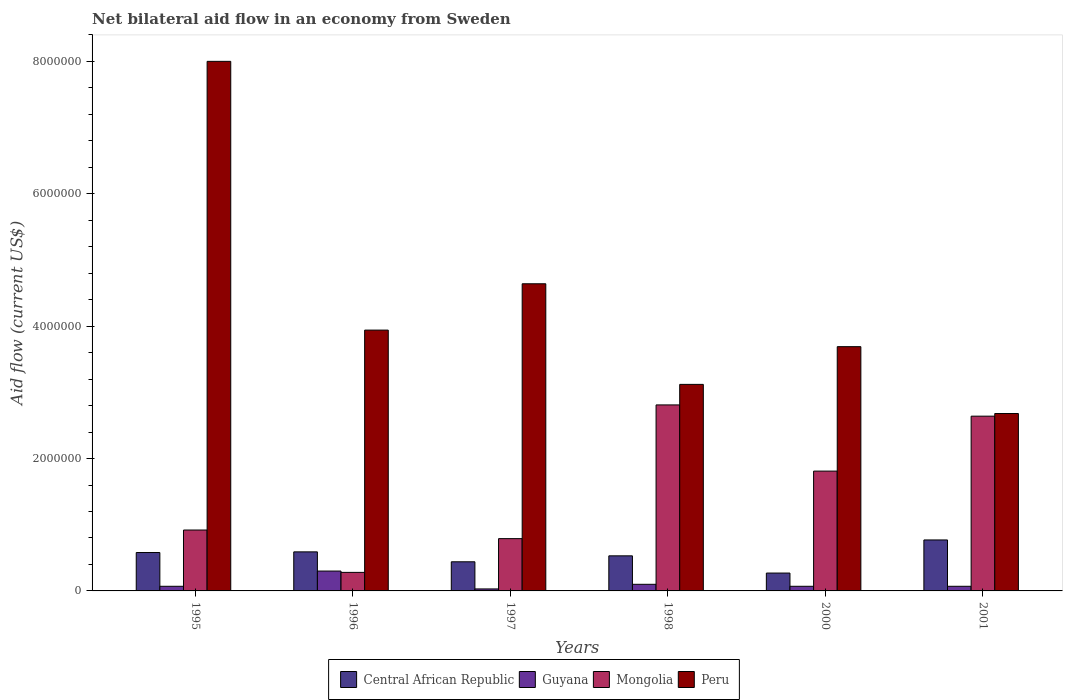How many different coloured bars are there?
Offer a very short reply. 4. How many groups of bars are there?
Make the answer very short. 6. Are the number of bars on each tick of the X-axis equal?
Make the answer very short. Yes. What is the net bilateral aid flow in Guyana in 2001?
Provide a short and direct response. 7.00e+04. Across all years, what is the minimum net bilateral aid flow in Central African Republic?
Make the answer very short. 2.70e+05. What is the total net bilateral aid flow in Mongolia in the graph?
Make the answer very short. 9.25e+06. What is the difference between the net bilateral aid flow in Mongolia in 1997 and that in 2000?
Give a very brief answer. -1.02e+06. What is the difference between the net bilateral aid flow in Mongolia in 1997 and the net bilateral aid flow in Central African Republic in 2001?
Make the answer very short. 2.00e+04. What is the average net bilateral aid flow in Guyana per year?
Provide a succinct answer. 1.07e+05. In the year 2000, what is the difference between the net bilateral aid flow in Central African Republic and net bilateral aid flow in Guyana?
Your answer should be very brief. 2.00e+05. What is the ratio of the net bilateral aid flow in Mongolia in 1996 to that in 2001?
Your response must be concise. 0.11. Is the net bilateral aid flow in Guyana in 1995 less than that in 1996?
Your response must be concise. Yes. Is the difference between the net bilateral aid flow in Central African Republic in 1997 and 2000 greater than the difference between the net bilateral aid flow in Guyana in 1997 and 2000?
Give a very brief answer. Yes. What does the 3rd bar from the left in 1998 represents?
Offer a very short reply. Mongolia. How many bars are there?
Provide a short and direct response. 24. Are all the bars in the graph horizontal?
Your answer should be compact. No. How many years are there in the graph?
Ensure brevity in your answer.  6. Are the values on the major ticks of Y-axis written in scientific E-notation?
Provide a short and direct response. No. Where does the legend appear in the graph?
Give a very brief answer. Bottom center. What is the title of the graph?
Your response must be concise. Net bilateral aid flow in an economy from Sweden. Does "Sub-Saharan Africa (developing only)" appear as one of the legend labels in the graph?
Keep it short and to the point. No. What is the Aid flow (current US$) of Central African Republic in 1995?
Offer a terse response. 5.80e+05. What is the Aid flow (current US$) of Mongolia in 1995?
Your response must be concise. 9.20e+05. What is the Aid flow (current US$) in Peru in 1995?
Offer a very short reply. 8.00e+06. What is the Aid flow (current US$) in Central African Republic in 1996?
Your response must be concise. 5.90e+05. What is the Aid flow (current US$) in Mongolia in 1996?
Your response must be concise. 2.80e+05. What is the Aid flow (current US$) of Peru in 1996?
Your answer should be very brief. 3.94e+06. What is the Aid flow (current US$) of Central African Republic in 1997?
Provide a succinct answer. 4.40e+05. What is the Aid flow (current US$) in Mongolia in 1997?
Give a very brief answer. 7.90e+05. What is the Aid flow (current US$) in Peru in 1997?
Provide a short and direct response. 4.64e+06. What is the Aid flow (current US$) of Central African Republic in 1998?
Provide a succinct answer. 5.30e+05. What is the Aid flow (current US$) in Guyana in 1998?
Provide a succinct answer. 1.00e+05. What is the Aid flow (current US$) in Mongolia in 1998?
Your response must be concise. 2.81e+06. What is the Aid flow (current US$) in Peru in 1998?
Your answer should be compact. 3.12e+06. What is the Aid flow (current US$) of Central African Republic in 2000?
Offer a very short reply. 2.70e+05. What is the Aid flow (current US$) of Guyana in 2000?
Offer a very short reply. 7.00e+04. What is the Aid flow (current US$) of Mongolia in 2000?
Your answer should be very brief. 1.81e+06. What is the Aid flow (current US$) of Peru in 2000?
Provide a short and direct response. 3.69e+06. What is the Aid flow (current US$) of Central African Republic in 2001?
Your answer should be compact. 7.70e+05. What is the Aid flow (current US$) in Mongolia in 2001?
Your answer should be compact. 2.64e+06. What is the Aid flow (current US$) of Peru in 2001?
Make the answer very short. 2.68e+06. Across all years, what is the maximum Aid flow (current US$) in Central African Republic?
Keep it short and to the point. 7.70e+05. Across all years, what is the maximum Aid flow (current US$) in Mongolia?
Offer a very short reply. 2.81e+06. Across all years, what is the maximum Aid flow (current US$) of Peru?
Offer a very short reply. 8.00e+06. Across all years, what is the minimum Aid flow (current US$) of Guyana?
Offer a terse response. 3.00e+04. Across all years, what is the minimum Aid flow (current US$) in Peru?
Your answer should be compact. 2.68e+06. What is the total Aid flow (current US$) of Central African Republic in the graph?
Keep it short and to the point. 3.18e+06. What is the total Aid flow (current US$) of Guyana in the graph?
Ensure brevity in your answer.  6.40e+05. What is the total Aid flow (current US$) of Mongolia in the graph?
Provide a succinct answer. 9.25e+06. What is the total Aid flow (current US$) of Peru in the graph?
Provide a succinct answer. 2.61e+07. What is the difference between the Aid flow (current US$) in Mongolia in 1995 and that in 1996?
Give a very brief answer. 6.40e+05. What is the difference between the Aid flow (current US$) of Peru in 1995 and that in 1996?
Your response must be concise. 4.06e+06. What is the difference between the Aid flow (current US$) in Central African Republic in 1995 and that in 1997?
Provide a succinct answer. 1.40e+05. What is the difference between the Aid flow (current US$) in Mongolia in 1995 and that in 1997?
Keep it short and to the point. 1.30e+05. What is the difference between the Aid flow (current US$) of Peru in 1995 and that in 1997?
Your answer should be compact. 3.36e+06. What is the difference between the Aid flow (current US$) in Mongolia in 1995 and that in 1998?
Offer a very short reply. -1.89e+06. What is the difference between the Aid flow (current US$) in Peru in 1995 and that in 1998?
Keep it short and to the point. 4.88e+06. What is the difference between the Aid flow (current US$) of Central African Republic in 1995 and that in 2000?
Make the answer very short. 3.10e+05. What is the difference between the Aid flow (current US$) in Mongolia in 1995 and that in 2000?
Keep it short and to the point. -8.90e+05. What is the difference between the Aid flow (current US$) of Peru in 1995 and that in 2000?
Make the answer very short. 4.31e+06. What is the difference between the Aid flow (current US$) of Central African Republic in 1995 and that in 2001?
Offer a very short reply. -1.90e+05. What is the difference between the Aid flow (current US$) in Mongolia in 1995 and that in 2001?
Keep it short and to the point. -1.72e+06. What is the difference between the Aid flow (current US$) in Peru in 1995 and that in 2001?
Keep it short and to the point. 5.32e+06. What is the difference between the Aid flow (current US$) of Mongolia in 1996 and that in 1997?
Your answer should be compact. -5.10e+05. What is the difference between the Aid flow (current US$) of Peru in 1996 and that in 1997?
Give a very brief answer. -7.00e+05. What is the difference between the Aid flow (current US$) of Central African Republic in 1996 and that in 1998?
Offer a very short reply. 6.00e+04. What is the difference between the Aid flow (current US$) in Mongolia in 1996 and that in 1998?
Keep it short and to the point. -2.53e+06. What is the difference between the Aid flow (current US$) in Peru in 1996 and that in 1998?
Your response must be concise. 8.20e+05. What is the difference between the Aid flow (current US$) in Central African Republic in 1996 and that in 2000?
Make the answer very short. 3.20e+05. What is the difference between the Aid flow (current US$) of Mongolia in 1996 and that in 2000?
Ensure brevity in your answer.  -1.53e+06. What is the difference between the Aid flow (current US$) in Central African Republic in 1996 and that in 2001?
Your response must be concise. -1.80e+05. What is the difference between the Aid flow (current US$) of Guyana in 1996 and that in 2001?
Offer a very short reply. 2.30e+05. What is the difference between the Aid flow (current US$) in Mongolia in 1996 and that in 2001?
Offer a terse response. -2.36e+06. What is the difference between the Aid flow (current US$) in Peru in 1996 and that in 2001?
Offer a terse response. 1.26e+06. What is the difference between the Aid flow (current US$) of Central African Republic in 1997 and that in 1998?
Your answer should be compact. -9.00e+04. What is the difference between the Aid flow (current US$) in Guyana in 1997 and that in 1998?
Provide a succinct answer. -7.00e+04. What is the difference between the Aid flow (current US$) of Mongolia in 1997 and that in 1998?
Offer a very short reply. -2.02e+06. What is the difference between the Aid flow (current US$) in Peru in 1997 and that in 1998?
Provide a succinct answer. 1.52e+06. What is the difference between the Aid flow (current US$) in Guyana in 1997 and that in 2000?
Give a very brief answer. -4.00e+04. What is the difference between the Aid flow (current US$) of Mongolia in 1997 and that in 2000?
Make the answer very short. -1.02e+06. What is the difference between the Aid flow (current US$) of Peru in 1997 and that in 2000?
Ensure brevity in your answer.  9.50e+05. What is the difference between the Aid flow (current US$) of Central African Republic in 1997 and that in 2001?
Keep it short and to the point. -3.30e+05. What is the difference between the Aid flow (current US$) of Guyana in 1997 and that in 2001?
Ensure brevity in your answer.  -4.00e+04. What is the difference between the Aid flow (current US$) of Mongolia in 1997 and that in 2001?
Provide a short and direct response. -1.85e+06. What is the difference between the Aid flow (current US$) of Peru in 1997 and that in 2001?
Give a very brief answer. 1.96e+06. What is the difference between the Aid flow (current US$) of Peru in 1998 and that in 2000?
Ensure brevity in your answer.  -5.70e+05. What is the difference between the Aid flow (current US$) of Central African Republic in 1998 and that in 2001?
Make the answer very short. -2.40e+05. What is the difference between the Aid flow (current US$) in Mongolia in 1998 and that in 2001?
Provide a short and direct response. 1.70e+05. What is the difference between the Aid flow (current US$) in Central African Republic in 2000 and that in 2001?
Provide a succinct answer. -5.00e+05. What is the difference between the Aid flow (current US$) in Mongolia in 2000 and that in 2001?
Offer a very short reply. -8.30e+05. What is the difference between the Aid flow (current US$) of Peru in 2000 and that in 2001?
Your answer should be compact. 1.01e+06. What is the difference between the Aid flow (current US$) in Central African Republic in 1995 and the Aid flow (current US$) in Guyana in 1996?
Your response must be concise. 2.80e+05. What is the difference between the Aid flow (current US$) in Central African Republic in 1995 and the Aid flow (current US$) in Mongolia in 1996?
Keep it short and to the point. 3.00e+05. What is the difference between the Aid flow (current US$) of Central African Republic in 1995 and the Aid flow (current US$) of Peru in 1996?
Give a very brief answer. -3.36e+06. What is the difference between the Aid flow (current US$) in Guyana in 1995 and the Aid flow (current US$) in Mongolia in 1996?
Offer a very short reply. -2.10e+05. What is the difference between the Aid flow (current US$) of Guyana in 1995 and the Aid flow (current US$) of Peru in 1996?
Offer a very short reply. -3.87e+06. What is the difference between the Aid flow (current US$) in Mongolia in 1995 and the Aid flow (current US$) in Peru in 1996?
Keep it short and to the point. -3.02e+06. What is the difference between the Aid flow (current US$) in Central African Republic in 1995 and the Aid flow (current US$) in Guyana in 1997?
Your response must be concise. 5.50e+05. What is the difference between the Aid flow (current US$) of Central African Republic in 1995 and the Aid flow (current US$) of Peru in 1997?
Your answer should be very brief. -4.06e+06. What is the difference between the Aid flow (current US$) in Guyana in 1995 and the Aid flow (current US$) in Mongolia in 1997?
Your answer should be compact. -7.20e+05. What is the difference between the Aid flow (current US$) in Guyana in 1995 and the Aid flow (current US$) in Peru in 1997?
Your answer should be compact. -4.57e+06. What is the difference between the Aid flow (current US$) in Mongolia in 1995 and the Aid flow (current US$) in Peru in 1997?
Make the answer very short. -3.72e+06. What is the difference between the Aid flow (current US$) of Central African Republic in 1995 and the Aid flow (current US$) of Mongolia in 1998?
Give a very brief answer. -2.23e+06. What is the difference between the Aid flow (current US$) of Central African Republic in 1995 and the Aid flow (current US$) of Peru in 1998?
Give a very brief answer. -2.54e+06. What is the difference between the Aid flow (current US$) of Guyana in 1995 and the Aid flow (current US$) of Mongolia in 1998?
Give a very brief answer. -2.74e+06. What is the difference between the Aid flow (current US$) in Guyana in 1995 and the Aid flow (current US$) in Peru in 1998?
Ensure brevity in your answer.  -3.05e+06. What is the difference between the Aid flow (current US$) in Mongolia in 1995 and the Aid flow (current US$) in Peru in 1998?
Ensure brevity in your answer.  -2.20e+06. What is the difference between the Aid flow (current US$) of Central African Republic in 1995 and the Aid flow (current US$) of Guyana in 2000?
Give a very brief answer. 5.10e+05. What is the difference between the Aid flow (current US$) in Central African Republic in 1995 and the Aid flow (current US$) in Mongolia in 2000?
Provide a short and direct response. -1.23e+06. What is the difference between the Aid flow (current US$) in Central African Republic in 1995 and the Aid flow (current US$) in Peru in 2000?
Your response must be concise. -3.11e+06. What is the difference between the Aid flow (current US$) in Guyana in 1995 and the Aid flow (current US$) in Mongolia in 2000?
Keep it short and to the point. -1.74e+06. What is the difference between the Aid flow (current US$) in Guyana in 1995 and the Aid flow (current US$) in Peru in 2000?
Make the answer very short. -3.62e+06. What is the difference between the Aid flow (current US$) of Mongolia in 1995 and the Aid flow (current US$) of Peru in 2000?
Provide a short and direct response. -2.77e+06. What is the difference between the Aid flow (current US$) in Central African Republic in 1995 and the Aid flow (current US$) in Guyana in 2001?
Offer a very short reply. 5.10e+05. What is the difference between the Aid flow (current US$) of Central African Republic in 1995 and the Aid flow (current US$) of Mongolia in 2001?
Give a very brief answer. -2.06e+06. What is the difference between the Aid flow (current US$) in Central African Republic in 1995 and the Aid flow (current US$) in Peru in 2001?
Your response must be concise. -2.10e+06. What is the difference between the Aid flow (current US$) in Guyana in 1995 and the Aid flow (current US$) in Mongolia in 2001?
Your answer should be very brief. -2.57e+06. What is the difference between the Aid flow (current US$) in Guyana in 1995 and the Aid flow (current US$) in Peru in 2001?
Ensure brevity in your answer.  -2.61e+06. What is the difference between the Aid flow (current US$) of Mongolia in 1995 and the Aid flow (current US$) of Peru in 2001?
Offer a terse response. -1.76e+06. What is the difference between the Aid flow (current US$) of Central African Republic in 1996 and the Aid flow (current US$) of Guyana in 1997?
Your response must be concise. 5.60e+05. What is the difference between the Aid flow (current US$) of Central African Republic in 1996 and the Aid flow (current US$) of Peru in 1997?
Your response must be concise. -4.05e+06. What is the difference between the Aid flow (current US$) of Guyana in 1996 and the Aid flow (current US$) of Mongolia in 1997?
Make the answer very short. -4.90e+05. What is the difference between the Aid flow (current US$) of Guyana in 1996 and the Aid flow (current US$) of Peru in 1997?
Your response must be concise. -4.34e+06. What is the difference between the Aid flow (current US$) in Mongolia in 1996 and the Aid flow (current US$) in Peru in 1997?
Your response must be concise. -4.36e+06. What is the difference between the Aid flow (current US$) of Central African Republic in 1996 and the Aid flow (current US$) of Mongolia in 1998?
Keep it short and to the point. -2.22e+06. What is the difference between the Aid flow (current US$) in Central African Republic in 1996 and the Aid flow (current US$) in Peru in 1998?
Your response must be concise. -2.53e+06. What is the difference between the Aid flow (current US$) of Guyana in 1996 and the Aid flow (current US$) of Mongolia in 1998?
Offer a terse response. -2.51e+06. What is the difference between the Aid flow (current US$) of Guyana in 1996 and the Aid flow (current US$) of Peru in 1998?
Offer a terse response. -2.82e+06. What is the difference between the Aid flow (current US$) of Mongolia in 1996 and the Aid flow (current US$) of Peru in 1998?
Keep it short and to the point. -2.84e+06. What is the difference between the Aid flow (current US$) in Central African Republic in 1996 and the Aid flow (current US$) in Guyana in 2000?
Keep it short and to the point. 5.20e+05. What is the difference between the Aid flow (current US$) in Central African Republic in 1996 and the Aid flow (current US$) in Mongolia in 2000?
Your answer should be very brief. -1.22e+06. What is the difference between the Aid flow (current US$) of Central African Republic in 1996 and the Aid flow (current US$) of Peru in 2000?
Your answer should be compact. -3.10e+06. What is the difference between the Aid flow (current US$) in Guyana in 1996 and the Aid flow (current US$) in Mongolia in 2000?
Your response must be concise. -1.51e+06. What is the difference between the Aid flow (current US$) in Guyana in 1996 and the Aid flow (current US$) in Peru in 2000?
Your response must be concise. -3.39e+06. What is the difference between the Aid flow (current US$) of Mongolia in 1996 and the Aid flow (current US$) of Peru in 2000?
Your answer should be very brief. -3.41e+06. What is the difference between the Aid flow (current US$) in Central African Republic in 1996 and the Aid flow (current US$) in Guyana in 2001?
Give a very brief answer. 5.20e+05. What is the difference between the Aid flow (current US$) in Central African Republic in 1996 and the Aid flow (current US$) in Mongolia in 2001?
Keep it short and to the point. -2.05e+06. What is the difference between the Aid flow (current US$) of Central African Republic in 1996 and the Aid flow (current US$) of Peru in 2001?
Your response must be concise. -2.09e+06. What is the difference between the Aid flow (current US$) of Guyana in 1996 and the Aid flow (current US$) of Mongolia in 2001?
Provide a succinct answer. -2.34e+06. What is the difference between the Aid flow (current US$) in Guyana in 1996 and the Aid flow (current US$) in Peru in 2001?
Your answer should be compact. -2.38e+06. What is the difference between the Aid flow (current US$) in Mongolia in 1996 and the Aid flow (current US$) in Peru in 2001?
Your answer should be very brief. -2.40e+06. What is the difference between the Aid flow (current US$) in Central African Republic in 1997 and the Aid flow (current US$) in Mongolia in 1998?
Offer a terse response. -2.37e+06. What is the difference between the Aid flow (current US$) of Central African Republic in 1997 and the Aid flow (current US$) of Peru in 1998?
Your response must be concise. -2.68e+06. What is the difference between the Aid flow (current US$) of Guyana in 1997 and the Aid flow (current US$) of Mongolia in 1998?
Provide a short and direct response. -2.78e+06. What is the difference between the Aid flow (current US$) in Guyana in 1997 and the Aid flow (current US$) in Peru in 1998?
Ensure brevity in your answer.  -3.09e+06. What is the difference between the Aid flow (current US$) of Mongolia in 1997 and the Aid flow (current US$) of Peru in 1998?
Ensure brevity in your answer.  -2.33e+06. What is the difference between the Aid flow (current US$) of Central African Republic in 1997 and the Aid flow (current US$) of Guyana in 2000?
Your answer should be very brief. 3.70e+05. What is the difference between the Aid flow (current US$) in Central African Republic in 1997 and the Aid flow (current US$) in Mongolia in 2000?
Your answer should be compact. -1.37e+06. What is the difference between the Aid flow (current US$) of Central African Republic in 1997 and the Aid flow (current US$) of Peru in 2000?
Your response must be concise. -3.25e+06. What is the difference between the Aid flow (current US$) of Guyana in 1997 and the Aid flow (current US$) of Mongolia in 2000?
Your answer should be very brief. -1.78e+06. What is the difference between the Aid flow (current US$) of Guyana in 1997 and the Aid flow (current US$) of Peru in 2000?
Ensure brevity in your answer.  -3.66e+06. What is the difference between the Aid flow (current US$) in Mongolia in 1997 and the Aid flow (current US$) in Peru in 2000?
Provide a short and direct response. -2.90e+06. What is the difference between the Aid flow (current US$) of Central African Republic in 1997 and the Aid flow (current US$) of Mongolia in 2001?
Your response must be concise. -2.20e+06. What is the difference between the Aid flow (current US$) in Central African Republic in 1997 and the Aid flow (current US$) in Peru in 2001?
Provide a short and direct response. -2.24e+06. What is the difference between the Aid flow (current US$) in Guyana in 1997 and the Aid flow (current US$) in Mongolia in 2001?
Your answer should be very brief. -2.61e+06. What is the difference between the Aid flow (current US$) of Guyana in 1997 and the Aid flow (current US$) of Peru in 2001?
Offer a terse response. -2.65e+06. What is the difference between the Aid flow (current US$) in Mongolia in 1997 and the Aid flow (current US$) in Peru in 2001?
Offer a terse response. -1.89e+06. What is the difference between the Aid flow (current US$) of Central African Republic in 1998 and the Aid flow (current US$) of Guyana in 2000?
Your answer should be compact. 4.60e+05. What is the difference between the Aid flow (current US$) in Central African Republic in 1998 and the Aid flow (current US$) in Mongolia in 2000?
Your answer should be compact. -1.28e+06. What is the difference between the Aid flow (current US$) of Central African Republic in 1998 and the Aid flow (current US$) of Peru in 2000?
Give a very brief answer. -3.16e+06. What is the difference between the Aid flow (current US$) of Guyana in 1998 and the Aid flow (current US$) of Mongolia in 2000?
Make the answer very short. -1.71e+06. What is the difference between the Aid flow (current US$) in Guyana in 1998 and the Aid flow (current US$) in Peru in 2000?
Keep it short and to the point. -3.59e+06. What is the difference between the Aid flow (current US$) in Mongolia in 1998 and the Aid flow (current US$) in Peru in 2000?
Offer a very short reply. -8.80e+05. What is the difference between the Aid flow (current US$) in Central African Republic in 1998 and the Aid flow (current US$) in Guyana in 2001?
Make the answer very short. 4.60e+05. What is the difference between the Aid flow (current US$) in Central African Republic in 1998 and the Aid flow (current US$) in Mongolia in 2001?
Offer a terse response. -2.11e+06. What is the difference between the Aid flow (current US$) in Central African Republic in 1998 and the Aid flow (current US$) in Peru in 2001?
Ensure brevity in your answer.  -2.15e+06. What is the difference between the Aid flow (current US$) of Guyana in 1998 and the Aid flow (current US$) of Mongolia in 2001?
Give a very brief answer. -2.54e+06. What is the difference between the Aid flow (current US$) of Guyana in 1998 and the Aid flow (current US$) of Peru in 2001?
Provide a short and direct response. -2.58e+06. What is the difference between the Aid flow (current US$) in Mongolia in 1998 and the Aid flow (current US$) in Peru in 2001?
Make the answer very short. 1.30e+05. What is the difference between the Aid flow (current US$) in Central African Republic in 2000 and the Aid flow (current US$) in Guyana in 2001?
Offer a very short reply. 2.00e+05. What is the difference between the Aid flow (current US$) of Central African Republic in 2000 and the Aid flow (current US$) of Mongolia in 2001?
Make the answer very short. -2.37e+06. What is the difference between the Aid flow (current US$) of Central African Republic in 2000 and the Aid flow (current US$) of Peru in 2001?
Offer a very short reply. -2.41e+06. What is the difference between the Aid flow (current US$) of Guyana in 2000 and the Aid flow (current US$) of Mongolia in 2001?
Make the answer very short. -2.57e+06. What is the difference between the Aid flow (current US$) of Guyana in 2000 and the Aid flow (current US$) of Peru in 2001?
Your answer should be compact. -2.61e+06. What is the difference between the Aid flow (current US$) in Mongolia in 2000 and the Aid flow (current US$) in Peru in 2001?
Ensure brevity in your answer.  -8.70e+05. What is the average Aid flow (current US$) of Central African Republic per year?
Your response must be concise. 5.30e+05. What is the average Aid flow (current US$) of Guyana per year?
Your response must be concise. 1.07e+05. What is the average Aid flow (current US$) of Mongolia per year?
Ensure brevity in your answer.  1.54e+06. What is the average Aid flow (current US$) in Peru per year?
Keep it short and to the point. 4.34e+06. In the year 1995, what is the difference between the Aid flow (current US$) of Central African Republic and Aid flow (current US$) of Guyana?
Keep it short and to the point. 5.10e+05. In the year 1995, what is the difference between the Aid flow (current US$) of Central African Republic and Aid flow (current US$) of Mongolia?
Ensure brevity in your answer.  -3.40e+05. In the year 1995, what is the difference between the Aid flow (current US$) in Central African Republic and Aid flow (current US$) in Peru?
Your answer should be compact. -7.42e+06. In the year 1995, what is the difference between the Aid flow (current US$) in Guyana and Aid flow (current US$) in Mongolia?
Make the answer very short. -8.50e+05. In the year 1995, what is the difference between the Aid flow (current US$) of Guyana and Aid flow (current US$) of Peru?
Offer a terse response. -7.93e+06. In the year 1995, what is the difference between the Aid flow (current US$) in Mongolia and Aid flow (current US$) in Peru?
Provide a succinct answer. -7.08e+06. In the year 1996, what is the difference between the Aid flow (current US$) in Central African Republic and Aid flow (current US$) in Guyana?
Ensure brevity in your answer.  2.90e+05. In the year 1996, what is the difference between the Aid flow (current US$) in Central African Republic and Aid flow (current US$) in Mongolia?
Ensure brevity in your answer.  3.10e+05. In the year 1996, what is the difference between the Aid flow (current US$) in Central African Republic and Aid flow (current US$) in Peru?
Offer a terse response. -3.35e+06. In the year 1996, what is the difference between the Aid flow (current US$) in Guyana and Aid flow (current US$) in Peru?
Your response must be concise. -3.64e+06. In the year 1996, what is the difference between the Aid flow (current US$) in Mongolia and Aid flow (current US$) in Peru?
Make the answer very short. -3.66e+06. In the year 1997, what is the difference between the Aid flow (current US$) in Central African Republic and Aid flow (current US$) in Guyana?
Ensure brevity in your answer.  4.10e+05. In the year 1997, what is the difference between the Aid flow (current US$) of Central African Republic and Aid flow (current US$) of Mongolia?
Ensure brevity in your answer.  -3.50e+05. In the year 1997, what is the difference between the Aid flow (current US$) in Central African Republic and Aid flow (current US$) in Peru?
Your response must be concise. -4.20e+06. In the year 1997, what is the difference between the Aid flow (current US$) of Guyana and Aid flow (current US$) of Mongolia?
Your answer should be very brief. -7.60e+05. In the year 1997, what is the difference between the Aid flow (current US$) in Guyana and Aid flow (current US$) in Peru?
Give a very brief answer. -4.61e+06. In the year 1997, what is the difference between the Aid flow (current US$) in Mongolia and Aid flow (current US$) in Peru?
Your answer should be very brief. -3.85e+06. In the year 1998, what is the difference between the Aid flow (current US$) of Central African Republic and Aid flow (current US$) of Guyana?
Your answer should be compact. 4.30e+05. In the year 1998, what is the difference between the Aid flow (current US$) of Central African Republic and Aid flow (current US$) of Mongolia?
Your answer should be very brief. -2.28e+06. In the year 1998, what is the difference between the Aid flow (current US$) of Central African Republic and Aid flow (current US$) of Peru?
Your answer should be compact. -2.59e+06. In the year 1998, what is the difference between the Aid flow (current US$) of Guyana and Aid flow (current US$) of Mongolia?
Offer a very short reply. -2.71e+06. In the year 1998, what is the difference between the Aid flow (current US$) of Guyana and Aid flow (current US$) of Peru?
Offer a terse response. -3.02e+06. In the year 1998, what is the difference between the Aid flow (current US$) of Mongolia and Aid flow (current US$) of Peru?
Your answer should be very brief. -3.10e+05. In the year 2000, what is the difference between the Aid flow (current US$) in Central African Republic and Aid flow (current US$) in Mongolia?
Your response must be concise. -1.54e+06. In the year 2000, what is the difference between the Aid flow (current US$) of Central African Republic and Aid flow (current US$) of Peru?
Your answer should be very brief. -3.42e+06. In the year 2000, what is the difference between the Aid flow (current US$) in Guyana and Aid flow (current US$) in Mongolia?
Provide a short and direct response. -1.74e+06. In the year 2000, what is the difference between the Aid flow (current US$) of Guyana and Aid flow (current US$) of Peru?
Give a very brief answer. -3.62e+06. In the year 2000, what is the difference between the Aid flow (current US$) in Mongolia and Aid flow (current US$) in Peru?
Your answer should be compact. -1.88e+06. In the year 2001, what is the difference between the Aid flow (current US$) in Central African Republic and Aid flow (current US$) in Mongolia?
Your response must be concise. -1.87e+06. In the year 2001, what is the difference between the Aid flow (current US$) of Central African Republic and Aid flow (current US$) of Peru?
Your answer should be very brief. -1.91e+06. In the year 2001, what is the difference between the Aid flow (current US$) of Guyana and Aid flow (current US$) of Mongolia?
Offer a very short reply. -2.57e+06. In the year 2001, what is the difference between the Aid flow (current US$) of Guyana and Aid flow (current US$) of Peru?
Give a very brief answer. -2.61e+06. What is the ratio of the Aid flow (current US$) in Central African Republic in 1995 to that in 1996?
Offer a terse response. 0.98. What is the ratio of the Aid flow (current US$) in Guyana in 1995 to that in 1996?
Make the answer very short. 0.23. What is the ratio of the Aid flow (current US$) of Mongolia in 1995 to that in 1996?
Your answer should be very brief. 3.29. What is the ratio of the Aid flow (current US$) of Peru in 1995 to that in 1996?
Provide a succinct answer. 2.03. What is the ratio of the Aid flow (current US$) in Central African Republic in 1995 to that in 1997?
Your answer should be compact. 1.32. What is the ratio of the Aid flow (current US$) of Guyana in 1995 to that in 1997?
Offer a very short reply. 2.33. What is the ratio of the Aid flow (current US$) of Mongolia in 1995 to that in 1997?
Keep it short and to the point. 1.16. What is the ratio of the Aid flow (current US$) of Peru in 1995 to that in 1997?
Ensure brevity in your answer.  1.72. What is the ratio of the Aid flow (current US$) in Central African Republic in 1995 to that in 1998?
Your answer should be very brief. 1.09. What is the ratio of the Aid flow (current US$) in Mongolia in 1995 to that in 1998?
Your answer should be compact. 0.33. What is the ratio of the Aid flow (current US$) in Peru in 1995 to that in 1998?
Provide a succinct answer. 2.56. What is the ratio of the Aid flow (current US$) of Central African Republic in 1995 to that in 2000?
Offer a very short reply. 2.15. What is the ratio of the Aid flow (current US$) in Mongolia in 1995 to that in 2000?
Provide a short and direct response. 0.51. What is the ratio of the Aid flow (current US$) in Peru in 1995 to that in 2000?
Make the answer very short. 2.17. What is the ratio of the Aid flow (current US$) of Central African Republic in 1995 to that in 2001?
Offer a very short reply. 0.75. What is the ratio of the Aid flow (current US$) in Mongolia in 1995 to that in 2001?
Provide a short and direct response. 0.35. What is the ratio of the Aid flow (current US$) in Peru in 1995 to that in 2001?
Your answer should be very brief. 2.99. What is the ratio of the Aid flow (current US$) of Central African Republic in 1996 to that in 1997?
Your response must be concise. 1.34. What is the ratio of the Aid flow (current US$) of Mongolia in 1996 to that in 1997?
Provide a short and direct response. 0.35. What is the ratio of the Aid flow (current US$) in Peru in 1996 to that in 1997?
Keep it short and to the point. 0.85. What is the ratio of the Aid flow (current US$) in Central African Republic in 1996 to that in 1998?
Provide a succinct answer. 1.11. What is the ratio of the Aid flow (current US$) in Guyana in 1996 to that in 1998?
Ensure brevity in your answer.  3. What is the ratio of the Aid flow (current US$) in Mongolia in 1996 to that in 1998?
Your answer should be compact. 0.1. What is the ratio of the Aid flow (current US$) of Peru in 1996 to that in 1998?
Provide a short and direct response. 1.26. What is the ratio of the Aid flow (current US$) of Central African Republic in 1996 to that in 2000?
Provide a succinct answer. 2.19. What is the ratio of the Aid flow (current US$) in Guyana in 1996 to that in 2000?
Offer a terse response. 4.29. What is the ratio of the Aid flow (current US$) in Mongolia in 1996 to that in 2000?
Your answer should be very brief. 0.15. What is the ratio of the Aid flow (current US$) of Peru in 1996 to that in 2000?
Ensure brevity in your answer.  1.07. What is the ratio of the Aid flow (current US$) of Central African Republic in 1996 to that in 2001?
Provide a succinct answer. 0.77. What is the ratio of the Aid flow (current US$) in Guyana in 1996 to that in 2001?
Give a very brief answer. 4.29. What is the ratio of the Aid flow (current US$) in Mongolia in 1996 to that in 2001?
Keep it short and to the point. 0.11. What is the ratio of the Aid flow (current US$) in Peru in 1996 to that in 2001?
Your response must be concise. 1.47. What is the ratio of the Aid flow (current US$) in Central African Republic in 1997 to that in 1998?
Keep it short and to the point. 0.83. What is the ratio of the Aid flow (current US$) of Mongolia in 1997 to that in 1998?
Your response must be concise. 0.28. What is the ratio of the Aid flow (current US$) in Peru in 1997 to that in 1998?
Your answer should be very brief. 1.49. What is the ratio of the Aid flow (current US$) in Central African Republic in 1997 to that in 2000?
Your answer should be compact. 1.63. What is the ratio of the Aid flow (current US$) in Guyana in 1997 to that in 2000?
Ensure brevity in your answer.  0.43. What is the ratio of the Aid flow (current US$) of Mongolia in 1997 to that in 2000?
Provide a succinct answer. 0.44. What is the ratio of the Aid flow (current US$) in Peru in 1997 to that in 2000?
Your response must be concise. 1.26. What is the ratio of the Aid flow (current US$) of Guyana in 1997 to that in 2001?
Make the answer very short. 0.43. What is the ratio of the Aid flow (current US$) of Mongolia in 1997 to that in 2001?
Keep it short and to the point. 0.3. What is the ratio of the Aid flow (current US$) of Peru in 1997 to that in 2001?
Offer a very short reply. 1.73. What is the ratio of the Aid flow (current US$) in Central African Republic in 1998 to that in 2000?
Ensure brevity in your answer.  1.96. What is the ratio of the Aid flow (current US$) in Guyana in 1998 to that in 2000?
Your answer should be compact. 1.43. What is the ratio of the Aid flow (current US$) of Mongolia in 1998 to that in 2000?
Provide a short and direct response. 1.55. What is the ratio of the Aid flow (current US$) in Peru in 1998 to that in 2000?
Offer a terse response. 0.85. What is the ratio of the Aid flow (current US$) of Central African Republic in 1998 to that in 2001?
Keep it short and to the point. 0.69. What is the ratio of the Aid flow (current US$) in Guyana in 1998 to that in 2001?
Offer a very short reply. 1.43. What is the ratio of the Aid flow (current US$) of Mongolia in 1998 to that in 2001?
Your response must be concise. 1.06. What is the ratio of the Aid flow (current US$) in Peru in 1998 to that in 2001?
Make the answer very short. 1.16. What is the ratio of the Aid flow (current US$) of Central African Republic in 2000 to that in 2001?
Ensure brevity in your answer.  0.35. What is the ratio of the Aid flow (current US$) in Mongolia in 2000 to that in 2001?
Provide a succinct answer. 0.69. What is the ratio of the Aid flow (current US$) in Peru in 2000 to that in 2001?
Your answer should be compact. 1.38. What is the difference between the highest and the second highest Aid flow (current US$) of Mongolia?
Give a very brief answer. 1.70e+05. What is the difference between the highest and the second highest Aid flow (current US$) in Peru?
Offer a very short reply. 3.36e+06. What is the difference between the highest and the lowest Aid flow (current US$) in Mongolia?
Give a very brief answer. 2.53e+06. What is the difference between the highest and the lowest Aid flow (current US$) of Peru?
Offer a very short reply. 5.32e+06. 